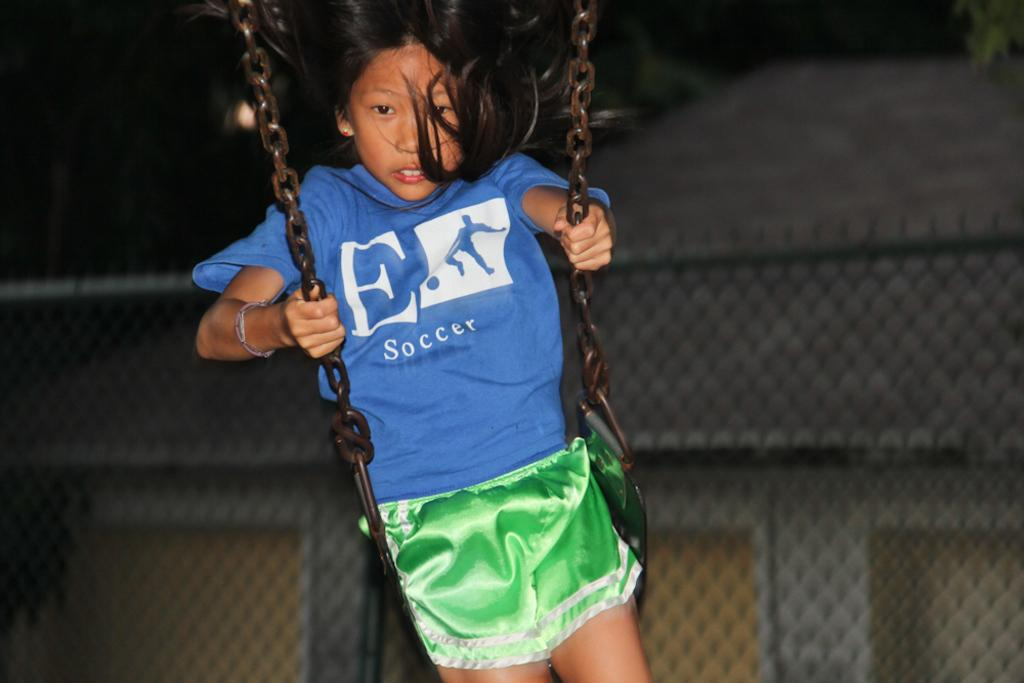<image>
Relay a brief, clear account of the picture shown. Girl wearing  shirt that says "Soccer" swinging on the swings. 